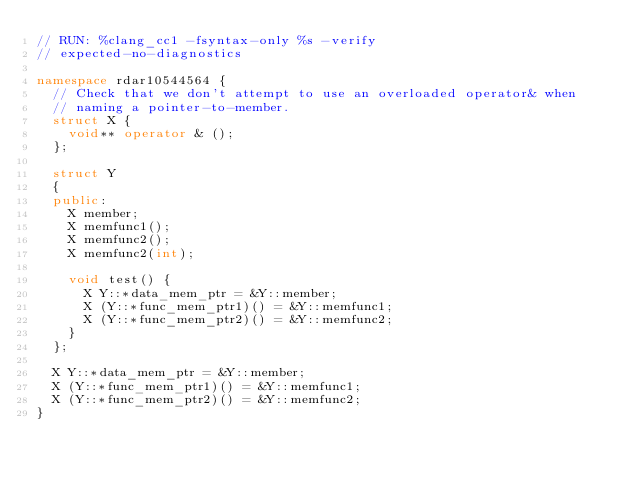Convert code to text. <code><loc_0><loc_0><loc_500><loc_500><_C++_>// RUN: %clang_cc1 -fsyntax-only %s -verify 
// expected-no-diagnostics

namespace rdar10544564 {
  // Check that we don't attempt to use an overloaded operator& when
  // naming a pointer-to-member.
  struct X {
    void** operator & ();
  };

  struct Y
  {
  public:
    X member;
    X memfunc1();
    X memfunc2();
    X memfunc2(int);

    void test() {
      X Y::*data_mem_ptr = &Y::member;
      X (Y::*func_mem_ptr1)() = &Y::memfunc1;
      X (Y::*func_mem_ptr2)() = &Y::memfunc2;
    }
  };
  
  X Y::*data_mem_ptr = &Y::member;
  X (Y::*func_mem_ptr1)() = &Y::memfunc1;
  X (Y::*func_mem_ptr2)() = &Y::memfunc2;
}
</code> 